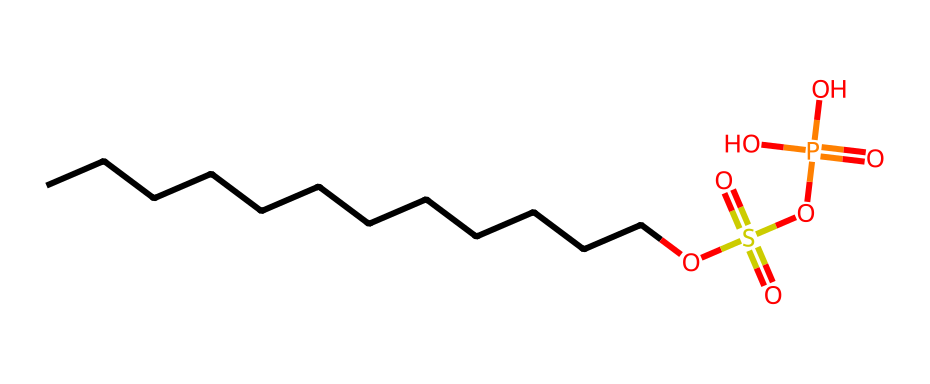What type of compound is represented by the given SMILES? The presence of phosphorus in the structure, along with sulfonic acid and alcohol functionalities, indicates that this compound is a phosphonate or phosphate ester.
Answer: phosphate How many oxygen atoms are present in this compound? By analyzing the SMILES, we identify the structural components: there are four O atoms in the phosphate group and two in the sulfonate group, giving a total of six oxygen atoms.
Answer: six What does the 'S(=O)(=O)' part of the SMILES indicate? This portion denotes a sulfonate group, recognized by the sulfur atom bonded to two oxygen atoms through double bonds, which is characteristic of sulfonate functionalities.
Answer: sulfonate What is the role of the long carbon chain (CCCCCCCCCCCC) in this molecule? The long carbon chain acts as a hydrophobic tail, which is essential for the surfactant properties of detergents, allowing the molecule to interact with oils and dirt.
Answer: hydrophobic tail How many phosphorus atoms are present in the molecular structure? The SMILES notation shows one phosphorus atom indicated by '[P]', thus confirming the presence of a single phosphorus atom in the compound.
Answer: one What type of bond is formed between the carbon chain and the phosphate group? The bond between the carbon chain and the phosphate is a single covalent bond, identified as the carbon is connected directly to the oxygen of the phosphate group in the structure.
Answer: single covalent bond What property of this compound makes it suitable for use in cleaning products? The combination of hydrophilic (phosphate) and hydrophobic (carbon chain) regions enables effective interaction with both water and oils, making it an effective surfactant for cleaning.
Answer: surfactant 